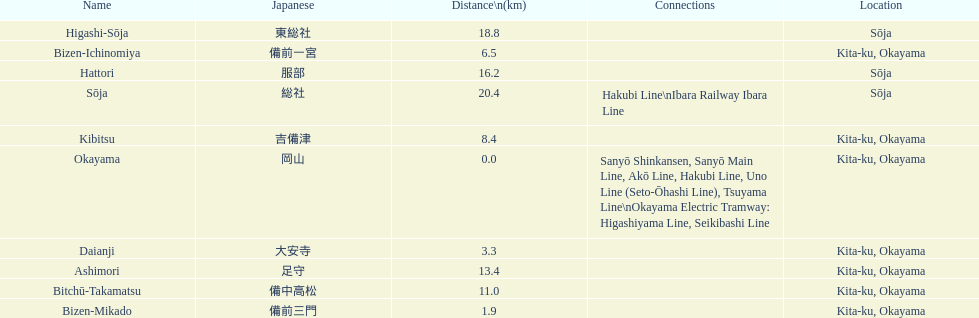How many continuous stops do you have to go through when boarding the kibi line at bizen-mikado and leaving at kibitsu? 2. 